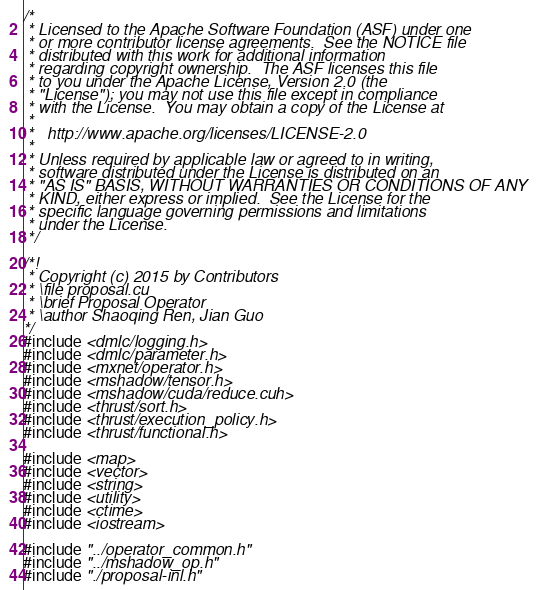Convert code to text. <code><loc_0><loc_0><loc_500><loc_500><_Cuda_>/*
 * Licensed to the Apache Software Foundation (ASF) under one
 * or more contributor license agreements.  See the NOTICE file
 * distributed with this work for additional information
 * regarding copyright ownership.  The ASF licenses this file
 * to you under the Apache License, Version 2.0 (the
 * "License"); you may not use this file except in compliance
 * with the License.  You may obtain a copy of the License at
 *
 *   http://www.apache.org/licenses/LICENSE-2.0
 *
 * Unless required by applicable law or agreed to in writing,
 * software distributed under the License is distributed on an
 * "AS IS" BASIS, WITHOUT WARRANTIES OR CONDITIONS OF ANY
 * KIND, either express or implied.  See the License for the
 * specific language governing permissions and limitations
 * under the License.
 */

/*!
 * Copyright (c) 2015 by Contributors
 * \file proposal.cu
 * \brief Proposal Operator
 * \author Shaoqing Ren, Jian Guo
*/
#include <dmlc/logging.h>
#include <dmlc/parameter.h>
#include <mxnet/operator.h>
#include <mshadow/tensor.h>
#include <mshadow/cuda/reduce.cuh>
#include <thrust/sort.h>
#include <thrust/execution_policy.h>
#include <thrust/functional.h>

#include <map>
#include <vector>
#include <string>
#include <utility>
#include <ctime>
#include <iostream>

#include "../operator_common.h"
#include "../mshadow_op.h"
#include "./proposal-inl.h"
</code> 